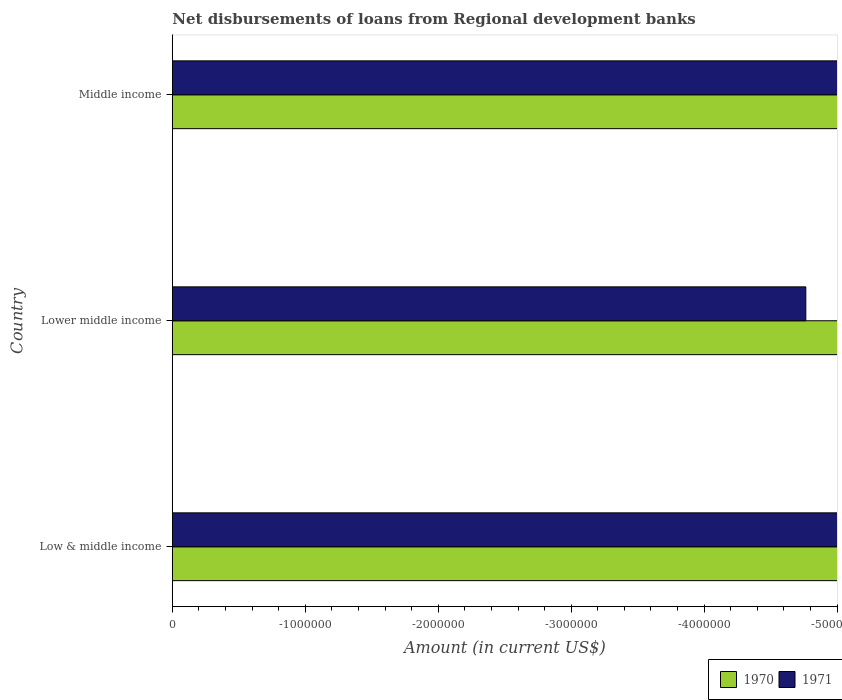Are the number of bars per tick equal to the number of legend labels?
Your response must be concise. No. Are the number of bars on each tick of the Y-axis equal?
Make the answer very short. Yes. How many bars are there on the 2nd tick from the top?
Your answer should be very brief. 0. How many bars are there on the 1st tick from the bottom?
Provide a short and direct response. 0. What is the label of the 3rd group of bars from the top?
Make the answer very short. Low & middle income. What is the amount of disbursements of loans from regional development banks in 1971 in Lower middle income?
Your response must be concise. 0. What is the total amount of disbursements of loans from regional development banks in 1971 in the graph?
Your response must be concise. 0. In how many countries, is the amount of disbursements of loans from regional development banks in 1970 greater than -1200000 US$?
Give a very brief answer. 0. In how many countries, is the amount of disbursements of loans from regional development banks in 1971 greater than the average amount of disbursements of loans from regional development banks in 1971 taken over all countries?
Ensure brevity in your answer.  0. How many bars are there?
Your answer should be compact. 0. Are the values on the major ticks of X-axis written in scientific E-notation?
Ensure brevity in your answer.  No. How many legend labels are there?
Give a very brief answer. 2. How are the legend labels stacked?
Keep it short and to the point. Horizontal. What is the title of the graph?
Provide a short and direct response. Net disbursements of loans from Regional development banks. What is the label or title of the Y-axis?
Ensure brevity in your answer.  Country. What is the Amount (in current US$) of 1971 in Low & middle income?
Your answer should be compact. 0. What is the Amount (in current US$) in 1970 in Lower middle income?
Offer a terse response. 0. What is the total Amount (in current US$) in 1970 in the graph?
Make the answer very short. 0. What is the total Amount (in current US$) of 1971 in the graph?
Keep it short and to the point. 0. 